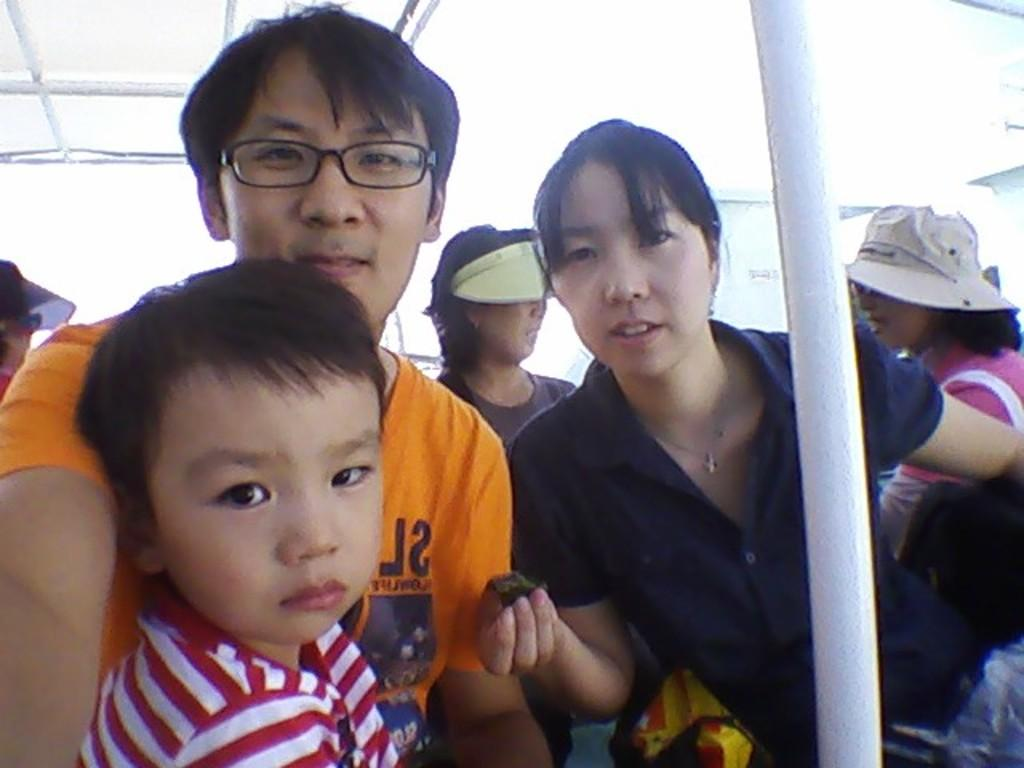How many people are in the image? There are people in the image, but the exact number is not specified. What is the woman holding in her hand? The woman is holding an object in her hand, but the specific object is not described. Can you describe any other objects or features in the image? There is a white color pole in the image. Can you see any mountains covered in fog in the image? There is no mention of mountains or fog in the image, so it cannot be determined if they are present. Is there any coal visible in the image? There is no mention of coal in the image, so it cannot be determined if it is present. 